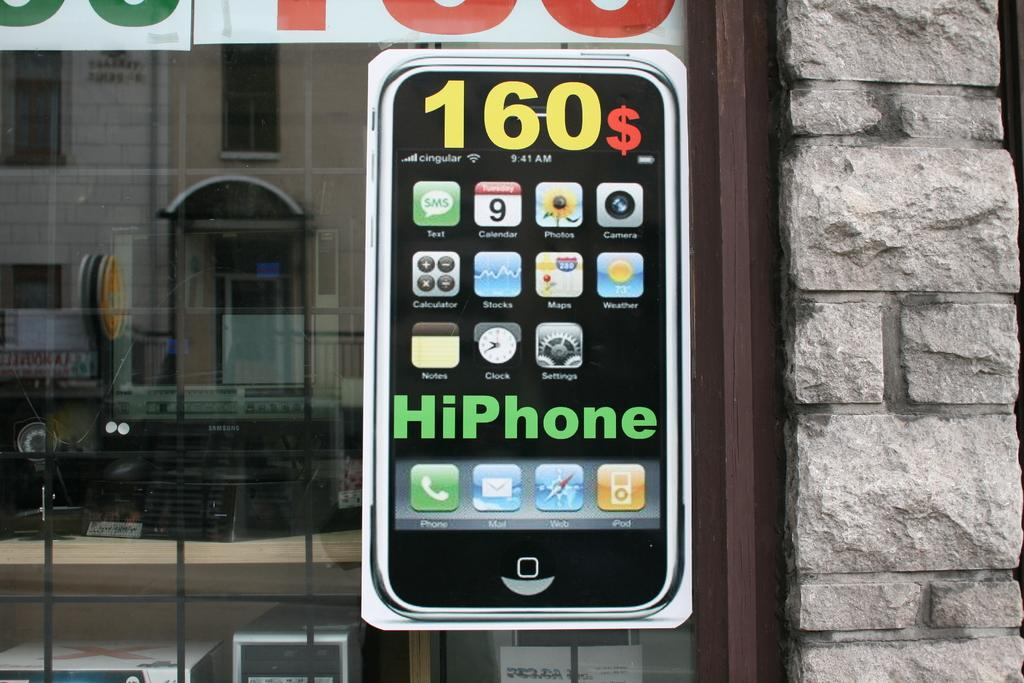<image>
Share a concise interpretation of the image provided. An advertisement on a window shows one can buy a phone for 160$. 